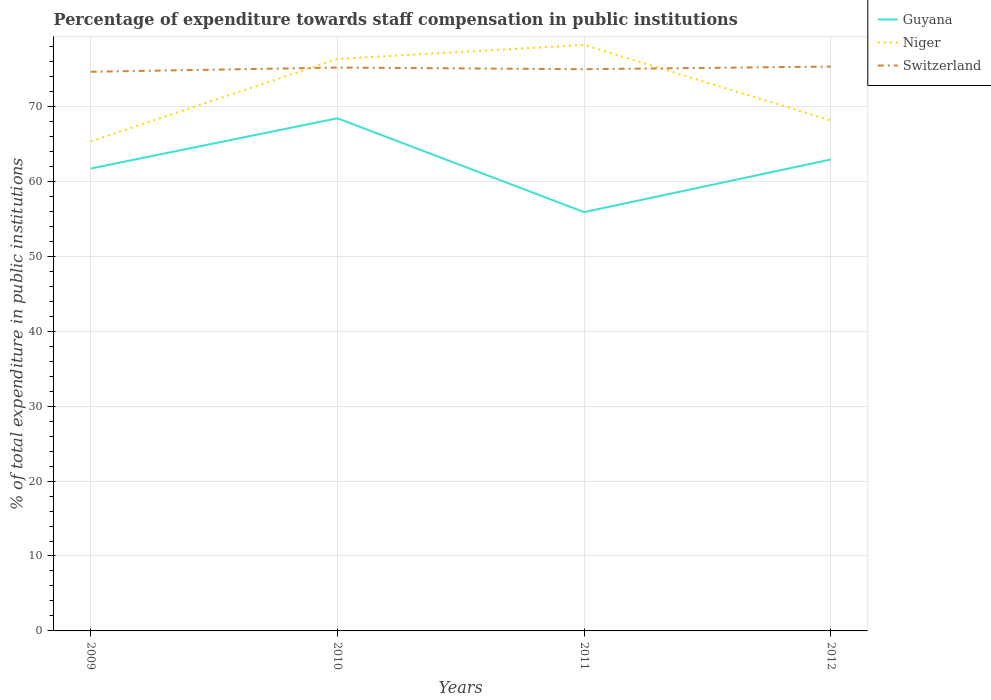Across all years, what is the maximum percentage of expenditure towards staff compensation in Switzerland?
Your response must be concise. 74.63. In which year was the percentage of expenditure towards staff compensation in Guyana maximum?
Offer a very short reply. 2011. What is the total percentage of expenditure towards staff compensation in Niger in the graph?
Offer a terse response. -11. What is the difference between the highest and the second highest percentage of expenditure towards staff compensation in Niger?
Keep it short and to the point. 12.87. What is the difference between the highest and the lowest percentage of expenditure towards staff compensation in Switzerland?
Offer a very short reply. 2. Is the percentage of expenditure towards staff compensation in Guyana strictly greater than the percentage of expenditure towards staff compensation in Switzerland over the years?
Provide a succinct answer. Yes. How many years are there in the graph?
Provide a short and direct response. 4. Are the values on the major ticks of Y-axis written in scientific E-notation?
Make the answer very short. No. Does the graph contain any zero values?
Your answer should be very brief. No. What is the title of the graph?
Give a very brief answer. Percentage of expenditure towards staff compensation in public institutions. Does "OECD members" appear as one of the legend labels in the graph?
Your answer should be compact. No. What is the label or title of the Y-axis?
Offer a terse response. % of total expenditure in public institutions. What is the % of total expenditure in public institutions of Guyana in 2009?
Provide a succinct answer. 61.71. What is the % of total expenditure in public institutions of Niger in 2009?
Offer a terse response. 65.34. What is the % of total expenditure in public institutions in Switzerland in 2009?
Offer a very short reply. 74.63. What is the % of total expenditure in public institutions of Guyana in 2010?
Offer a very short reply. 68.42. What is the % of total expenditure in public institutions of Niger in 2010?
Give a very brief answer. 76.34. What is the % of total expenditure in public institutions of Switzerland in 2010?
Offer a terse response. 75.19. What is the % of total expenditure in public institutions of Guyana in 2011?
Your response must be concise. 55.9. What is the % of total expenditure in public institutions in Niger in 2011?
Offer a very short reply. 78.21. What is the % of total expenditure in public institutions of Switzerland in 2011?
Keep it short and to the point. 74.97. What is the % of total expenditure in public institutions in Guyana in 2012?
Keep it short and to the point. 62.92. What is the % of total expenditure in public institutions in Niger in 2012?
Keep it short and to the point. 68.13. What is the % of total expenditure in public institutions of Switzerland in 2012?
Keep it short and to the point. 75.32. Across all years, what is the maximum % of total expenditure in public institutions of Guyana?
Give a very brief answer. 68.42. Across all years, what is the maximum % of total expenditure in public institutions in Niger?
Your response must be concise. 78.21. Across all years, what is the maximum % of total expenditure in public institutions of Switzerland?
Offer a very short reply. 75.32. Across all years, what is the minimum % of total expenditure in public institutions of Guyana?
Your answer should be very brief. 55.9. Across all years, what is the minimum % of total expenditure in public institutions of Niger?
Provide a short and direct response. 65.34. Across all years, what is the minimum % of total expenditure in public institutions in Switzerland?
Provide a short and direct response. 74.63. What is the total % of total expenditure in public institutions in Guyana in the graph?
Provide a short and direct response. 248.96. What is the total % of total expenditure in public institutions of Niger in the graph?
Offer a terse response. 288.02. What is the total % of total expenditure in public institutions of Switzerland in the graph?
Keep it short and to the point. 300.11. What is the difference between the % of total expenditure in public institutions in Guyana in 2009 and that in 2010?
Provide a succinct answer. -6.71. What is the difference between the % of total expenditure in public institutions in Niger in 2009 and that in 2010?
Your answer should be very brief. -11. What is the difference between the % of total expenditure in public institutions in Switzerland in 2009 and that in 2010?
Keep it short and to the point. -0.56. What is the difference between the % of total expenditure in public institutions of Guyana in 2009 and that in 2011?
Provide a short and direct response. 5.82. What is the difference between the % of total expenditure in public institutions of Niger in 2009 and that in 2011?
Provide a short and direct response. -12.87. What is the difference between the % of total expenditure in public institutions in Switzerland in 2009 and that in 2011?
Keep it short and to the point. -0.34. What is the difference between the % of total expenditure in public institutions of Guyana in 2009 and that in 2012?
Offer a terse response. -1.21. What is the difference between the % of total expenditure in public institutions in Niger in 2009 and that in 2012?
Keep it short and to the point. -2.79. What is the difference between the % of total expenditure in public institutions of Switzerland in 2009 and that in 2012?
Your answer should be compact. -0.69. What is the difference between the % of total expenditure in public institutions of Guyana in 2010 and that in 2011?
Your answer should be compact. 12.53. What is the difference between the % of total expenditure in public institutions of Niger in 2010 and that in 2011?
Provide a succinct answer. -1.87. What is the difference between the % of total expenditure in public institutions of Switzerland in 2010 and that in 2011?
Offer a terse response. 0.22. What is the difference between the % of total expenditure in public institutions in Guyana in 2010 and that in 2012?
Offer a very short reply. 5.5. What is the difference between the % of total expenditure in public institutions in Niger in 2010 and that in 2012?
Offer a terse response. 8.21. What is the difference between the % of total expenditure in public institutions of Switzerland in 2010 and that in 2012?
Your response must be concise. -0.13. What is the difference between the % of total expenditure in public institutions of Guyana in 2011 and that in 2012?
Provide a short and direct response. -7.02. What is the difference between the % of total expenditure in public institutions of Niger in 2011 and that in 2012?
Your response must be concise. 10.08. What is the difference between the % of total expenditure in public institutions in Switzerland in 2011 and that in 2012?
Keep it short and to the point. -0.35. What is the difference between the % of total expenditure in public institutions in Guyana in 2009 and the % of total expenditure in public institutions in Niger in 2010?
Your answer should be compact. -14.62. What is the difference between the % of total expenditure in public institutions in Guyana in 2009 and the % of total expenditure in public institutions in Switzerland in 2010?
Give a very brief answer. -13.48. What is the difference between the % of total expenditure in public institutions in Niger in 2009 and the % of total expenditure in public institutions in Switzerland in 2010?
Offer a very short reply. -9.85. What is the difference between the % of total expenditure in public institutions of Guyana in 2009 and the % of total expenditure in public institutions of Niger in 2011?
Keep it short and to the point. -16.5. What is the difference between the % of total expenditure in public institutions of Guyana in 2009 and the % of total expenditure in public institutions of Switzerland in 2011?
Your answer should be compact. -13.26. What is the difference between the % of total expenditure in public institutions of Niger in 2009 and the % of total expenditure in public institutions of Switzerland in 2011?
Make the answer very short. -9.63. What is the difference between the % of total expenditure in public institutions in Guyana in 2009 and the % of total expenditure in public institutions in Niger in 2012?
Keep it short and to the point. -6.42. What is the difference between the % of total expenditure in public institutions of Guyana in 2009 and the % of total expenditure in public institutions of Switzerland in 2012?
Give a very brief answer. -13.61. What is the difference between the % of total expenditure in public institutions in Niger in 2009 and the % of total expenditure in public institutions in Switzerland in 2012?
Your answer should be compact. -9.98. What is the difference between the % of total expenditure in public institutions of Guyana in 2010 and the % of total expenditure in public institutions of Niger in 2011?
Your response must be concise. -9.79. What is the difference between the % of total expenditure in public institutions of Guyana in 2010 and the % of total expenditure in public institutions of Switzerland in 2011?
Your answer should be compact. -6.55. What is the difference between the % of total expenditure in public institutions in Niger in 2010 and the % of total expenditure in public institutions in Switzerland in 2011?
Offer a very short reply. 1.37. What is the difference between the % of total expenditure in public institutions in Guyana in 2010 and the % of total expenditure in public institutions in Niger in 2012?
Ensure brevity in your answer.  0.29. What is the difference between the % of total expenditure in public institutions of Guyana in 2010 and the % of total expenditure in public institutions of Switzerland in 2012?
Your answer should be compact. -6.9. What is the difference between the % of total expenditure in public institutions of Guyana in 2011 and the % of total expenditure in public institutions of Niger in 2012?
Your response must be concise. -12.23. What is the difference between the % of total expenditure in public institutions in Guyana in 2011 and the % of total expenditure in public institutions in Switzerland in 2012?
Ensure brevity in your answer.  -19.43. What is the difference between the % of total expenditure in public institutions in Niger in 2011 and the % of total expenditure in public institutions in Switzerland in 2012?
Ensure brevity in your answer.  2.89. What is the average % of total expenditure in public institutions in Guyana per year?
Give a very brief answer. 62.24. What is the average % of total expenditure in public institutions in Niger per year?
Keep it short and to the point. 72. What is the average % of total expenditure in public institutions of Switzerland per year?
Your response must be concise. 75.03. In the year 2009, what is the difference between the % of total expenditure in public institutions of Guyana and % of total expenditure in public institutions of Niger?
Your response must be concise. -3.62. In the year 2009, what is the difference between the % of total expenditure in public institutions in Guyana and % of total expenditure in public institutions in Switzerland?
Make the answer very short. -12.91. In the year 2009, what is the difference between the % of total expenditure in public institutions of Niger and % of total expenditure in public institutions of Switzerland?
Give a very brief answer. -9.29. In the year 2010, what is the difference between the % of total expenditure in public institutions of Guyana and % of total expenditure in public institutions of Niger?
Ensure brevity in your answer.  -7.92. In the year 2010, what is the difference between the % of total expenditure in public institutions of Guyana and % of total expenditure in public institutions of Switzerland?
Your response must be concise. -6.77. In the year 2010, what is the difference between the % of total expenditure in public institutions in Niger and % of total expenditure in public institutions in Switzerland?
Offer a very short reply. 1.15. In the year 2011, what is the difference between the % of total expenditure in public institutions of Guyana and % of total expenditure in public institutions of Niger?
Keep it short and to the point. -22.31. In the year 2011, what is the difference between the % of total expenditure in public institutions of Guyana and % of total expenditure in public institutions of Switzerland?
Ensure brevity in your answer.  -19.07. In the year 2011, what is the difference between the % of total expenditure in public institutions of Niger and % of total expenditure in public institutions of Switzerland?
Offer a very short reply. 3.24. In the year 2012, what is the difference between the % of total expenditure in public institutions in Guyana and % of total expenditure in public institutions in Niger?
Your response must be concise. -5.21. In the year 2012, what is the difference between the % of total expenditure in public institutions of Guyana and % of total expenditure in public institutions of Switzerland?
Make the answer very short. -12.4. In the year 2012, what is the difference between the % of total expenditure in public institutions in Niger and % of total expenditure in public institutions in Switzerland?
Ensure brevity in your answer.  -7.19. What is the ratio of the % of total expenditure in public institutions of Guyana in 2009 to that in 2010?
Offer a terse response. 0.9. What is the ratio of the % of total expenditure in public institutions of Niger in 2009 to that in 2010?
Keep it short and to the point. 0.86. What is the ratio of the % of total expenditure in public institutions in Guyana in 2009 to that in 2011?
Your response must be concise. 1.1. What is the ratio of the % of total expenditure in public institutions of Niger in 2009 to that in 2011?
Give a very brief answer. 0.84. What is the ratio of the % of total expenditure in public institutions in Switzerland in 2009 to that in 2011?
Your response must be concise. 1. What is the ratio of the % of total expenditure in public institutions of Guyana in 2009 to that in 2012?
Your response must be concise. 0.98. What is the ratio of the % of total expenditure in public institutions of Niger in 2009 to that in 2012?
Your response must be concise. 0.96. What is the ratio of the % of total expenditure in public institutions of Switzerland in 2009 to that in 2012?
Provide a succinct answer. 0.99. What is the ratio of the % of total expenditure in public institutions of Guyana in 2010 to that in 2011?
Your answer should be very brief. 1.22. What is the ratio of the % of total expenditure in public institutions of Niger in 2010 to that in 2011?
Ensure brevity in your answer.  0.98. What is the ratio of the % of total expenditure in public institutions of Guyana in 2010 to that in 2012?
Your answer should be compact. 1.09. What is the ratio of the % of total expenditure in public institutions in Niger in 2010 to that in 2012?
Make the answer very short. 1.12. What is the ratio of the % of total expenditure in public institutions of Switzerland in 2010 to that in 2012?
Your answer should be very brief. 1. What is the ratio of the % of total expenditure in public institutions of Guyana in 2011 to that in 2012?
Ensure brevity in your answer.  0.89. What is the ratio of the % of total expenditure in public institutions of Niger in 2011 to that in 2012?
Your response must be concise. 1.15. What is the ratio of the % of total expenditure in public institutions of Switzerland in 2011 to that in 2012?
Offer a terse response. 1. What is the difference between the highest and the second highest % of total expenditure in public institutions of Guyana?
Provide a succinct answer. 5.5. What is the difference between the highest and the second highest % of total expenditure in public institutions in Niger?
Your answer should be compact. 1.87. What is the difference between the highest and the second highest % of total expenditure in public institutions of Switzerland?
Ensure brevity in your answer.  0.13. What is the difference between the highest and the lowest % of total expenditure in public institutions in Guyana?
Offer a very short reply. 12.53. What is the difference between the highest and the lowest % of total expenditure in public institutions of Niger?
Make the answer very short. 12.87. What is the difference between the highest and the lowest % of total expenditure in public institutions in Switzerland?
Provide a short and direct response. 0.69. 